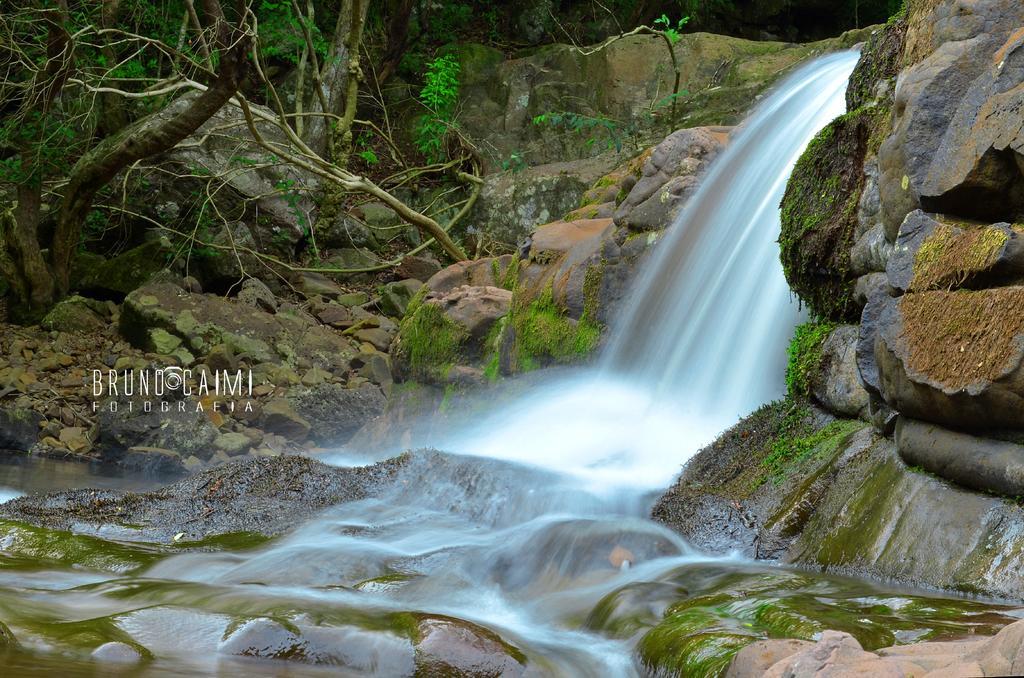Describe this image in one or two sentences. In this image we can see the waterfall, rocks, plants and trees. Here we can see the watermark on the left side of the image. 